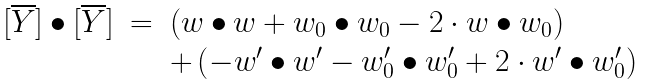<formula> <loc_0><loc_0><loc_500><loc_500>\begin{array} { r c l } [ \overline { Y } ] \bullet [ \overline { Y } ] & = & \left ( w \bullet w + w _ { 0 } \bullet w _ { 0 } - 2 \cdot w \bullet w _ { 0 } \right ) \\ & & + \left ( - w ^ { \prime } \bullet w ^ { \prime } - w _ { 0 } ^ { \prime } \bullet w _ { 0 } ^ { \prime } + 2 \cdot w ^ { \prime } \bullet w _ { 0 } ^ { \prime } \right ) \end{array}</formula> 